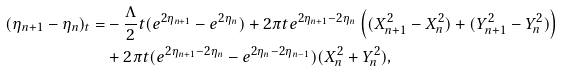Convert formula to latex. <formula><loc_0><loc_0><loc_500><loc_500>( \eta _ { n + 1 } - \eta _ { n } ) _ { t } = & - \frac { \Lambda } { 2 } t ( e ^ { 2 \eta _ { n + 1 } } - e ^ { 2 \eta _ { n } } ) + 2 \pi t e ^ { 2 \eta _ { n + 1 } - 2 \eta _ { n } } \left ( ( X _ { n + 1 } ^ { 2 } - X _ { n } ^ { 2 } ) + ( Y _ { n + 1 } ^ { 2 } - Y _ { n } ^ { 2 } ) \right ) \\ & + 2 \pi t ( e ^ { 2 \eta _ { n + 1 } - 2 \eta _ { n } } - e ^ { 2 \eta _ { n } - 2 \eta _ { n - 1 } } ) ( X _ { n } ^ { 2 } + Y _ { n } ^ { 2 } ) ,</formula> 